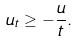Convert formula to latex. <formula><loc_0><loc_0><loc_500><loc_500>u _ { t } \geq - \frac { u } { t } .</formula> 